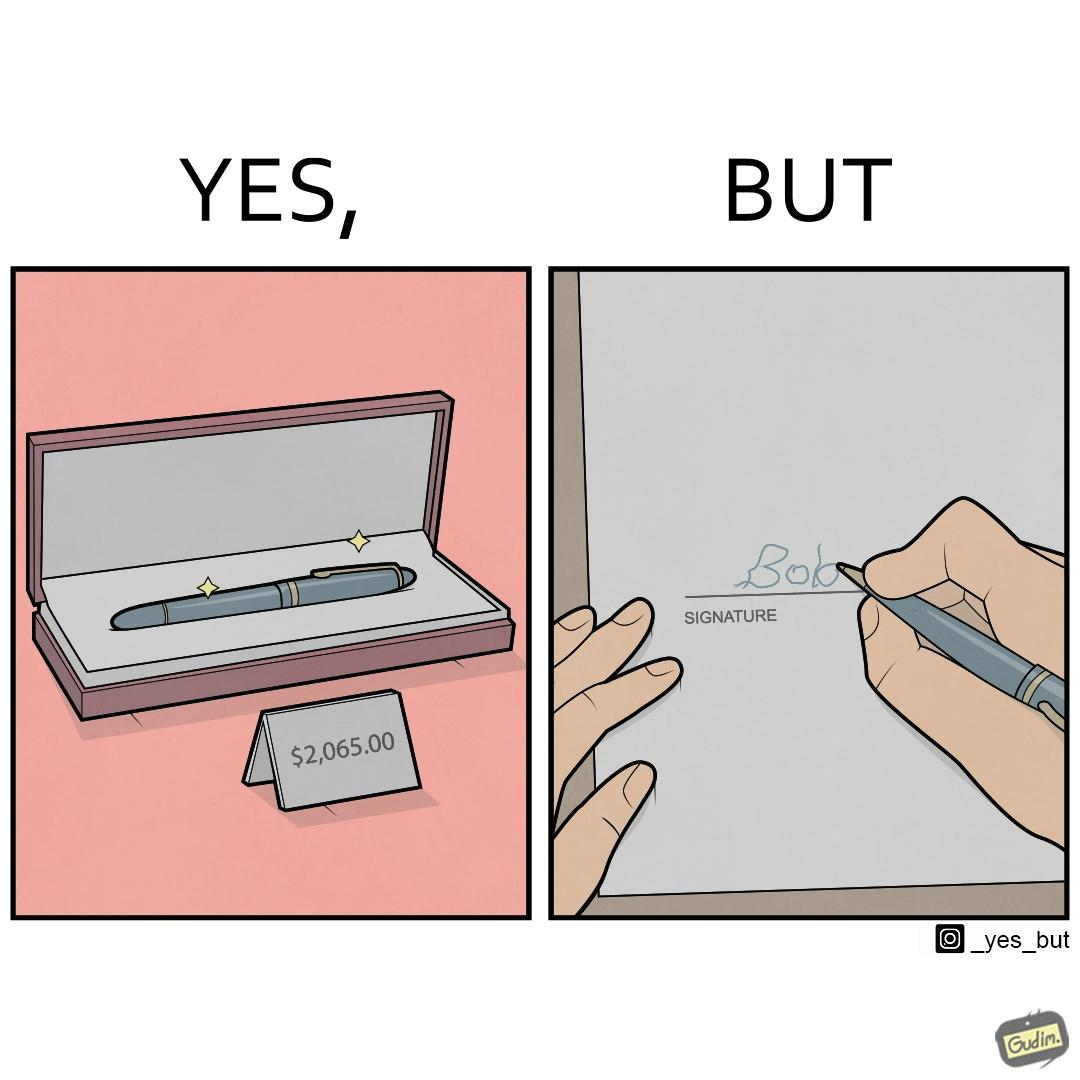Does this image contain satire or humor? Yes, this image is satirical. 